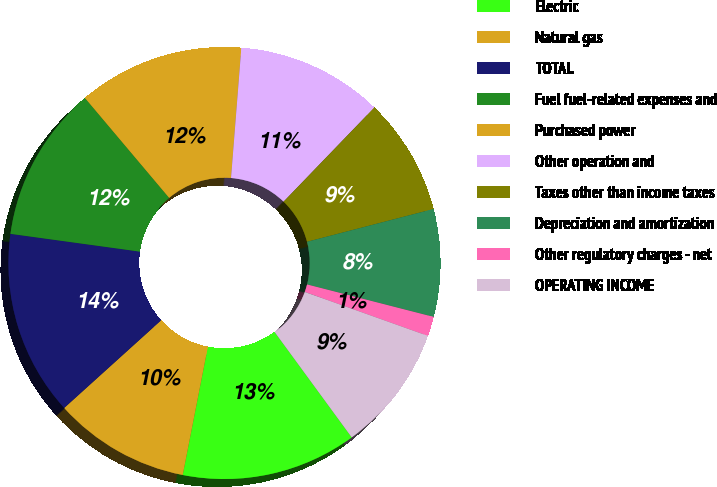Convert chart to OTSL. <chart><loc_0><loc_0><loc_500><loc_500><pie_chart><fcel>Electric<fcel>Natural gas<fcel>TOTAL<fcel>Fuel fuel-related expenses and<fcel>Purchased power<fcel>Other operation and<fcel>Taxes other than income taxes<fcel>Depreciation and amortization<fcel>Other regulatory charges - net<fcel>OPERATING INCOME<nl><fcel>13.14%<fcel>10.22%<fcel>13.87%<fcel>11.68%<fcel>12.41%<fcel>10.95%<fcel>8.76%<fcel>8.03%<fcel>1.46%<fcel>9.49%<nl></chart> 